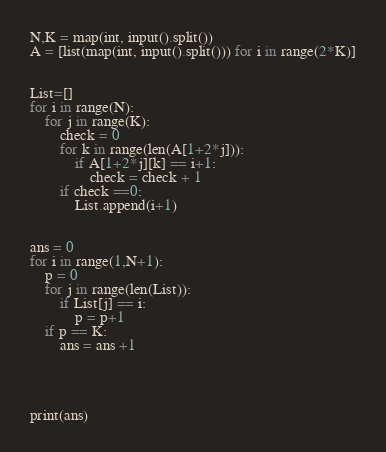Convert code to text. <code><loc_0><loc_0><loc_500><loc_500><_Python_>N,K = map(int, input().split())
A = [list(map(int, input().split())) for i in range(2*K)]


List=[]
for i in range(N):
    for j in range(K):
        check = 0
        for k in range(len(A[1+2*j])):
            if A[1+2*j][k] == i+1:
                check = check + 1
        if check ==0:
            List.append(i+1)


ans = 0
for i in range(1,N+1):
    p = 0
    for j in range(len(List)):
        if List[j] == i:
            p = p+1
    if p == K:
        ans = ans +1
        
        
    
            
print(ans)</code> 